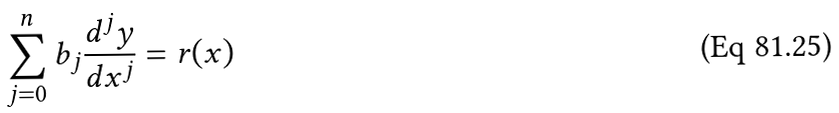<formula> <loc_0><loc_0><loc_500><loc_500>\sum _ { j = 0 } ^ { n } b _ { j } \frac { d ^ { j } y } { d x ^ { j } } = r ( x )</formula> 